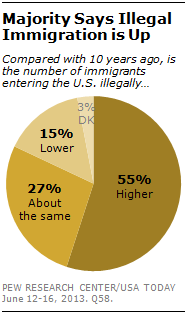Draw attention to some important aspects in this diagram. The difference between the highest and lowest value is 52 I, DK, am a color and my color is light yellow. 